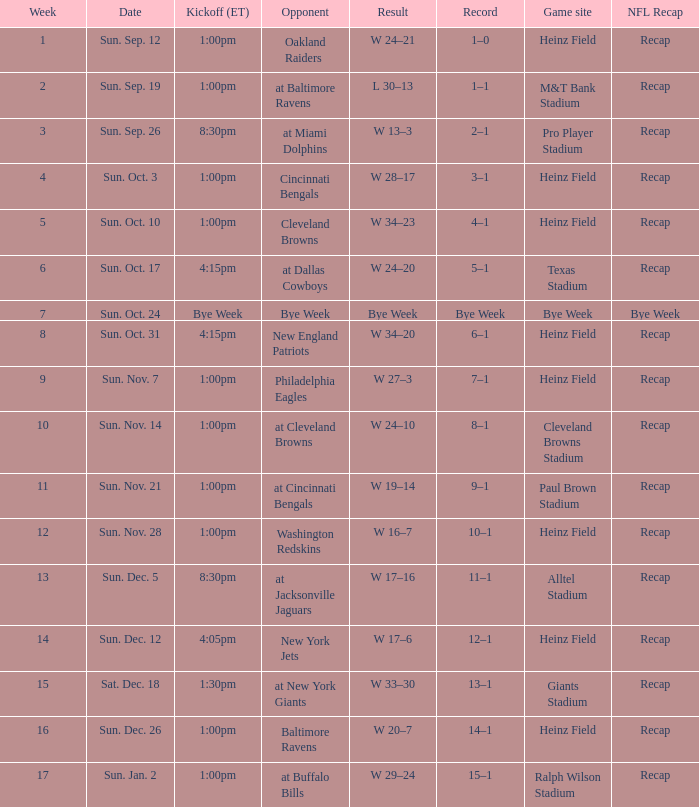Which Kickoff (ET) has a Result of w 34–23? 1:00pm. 